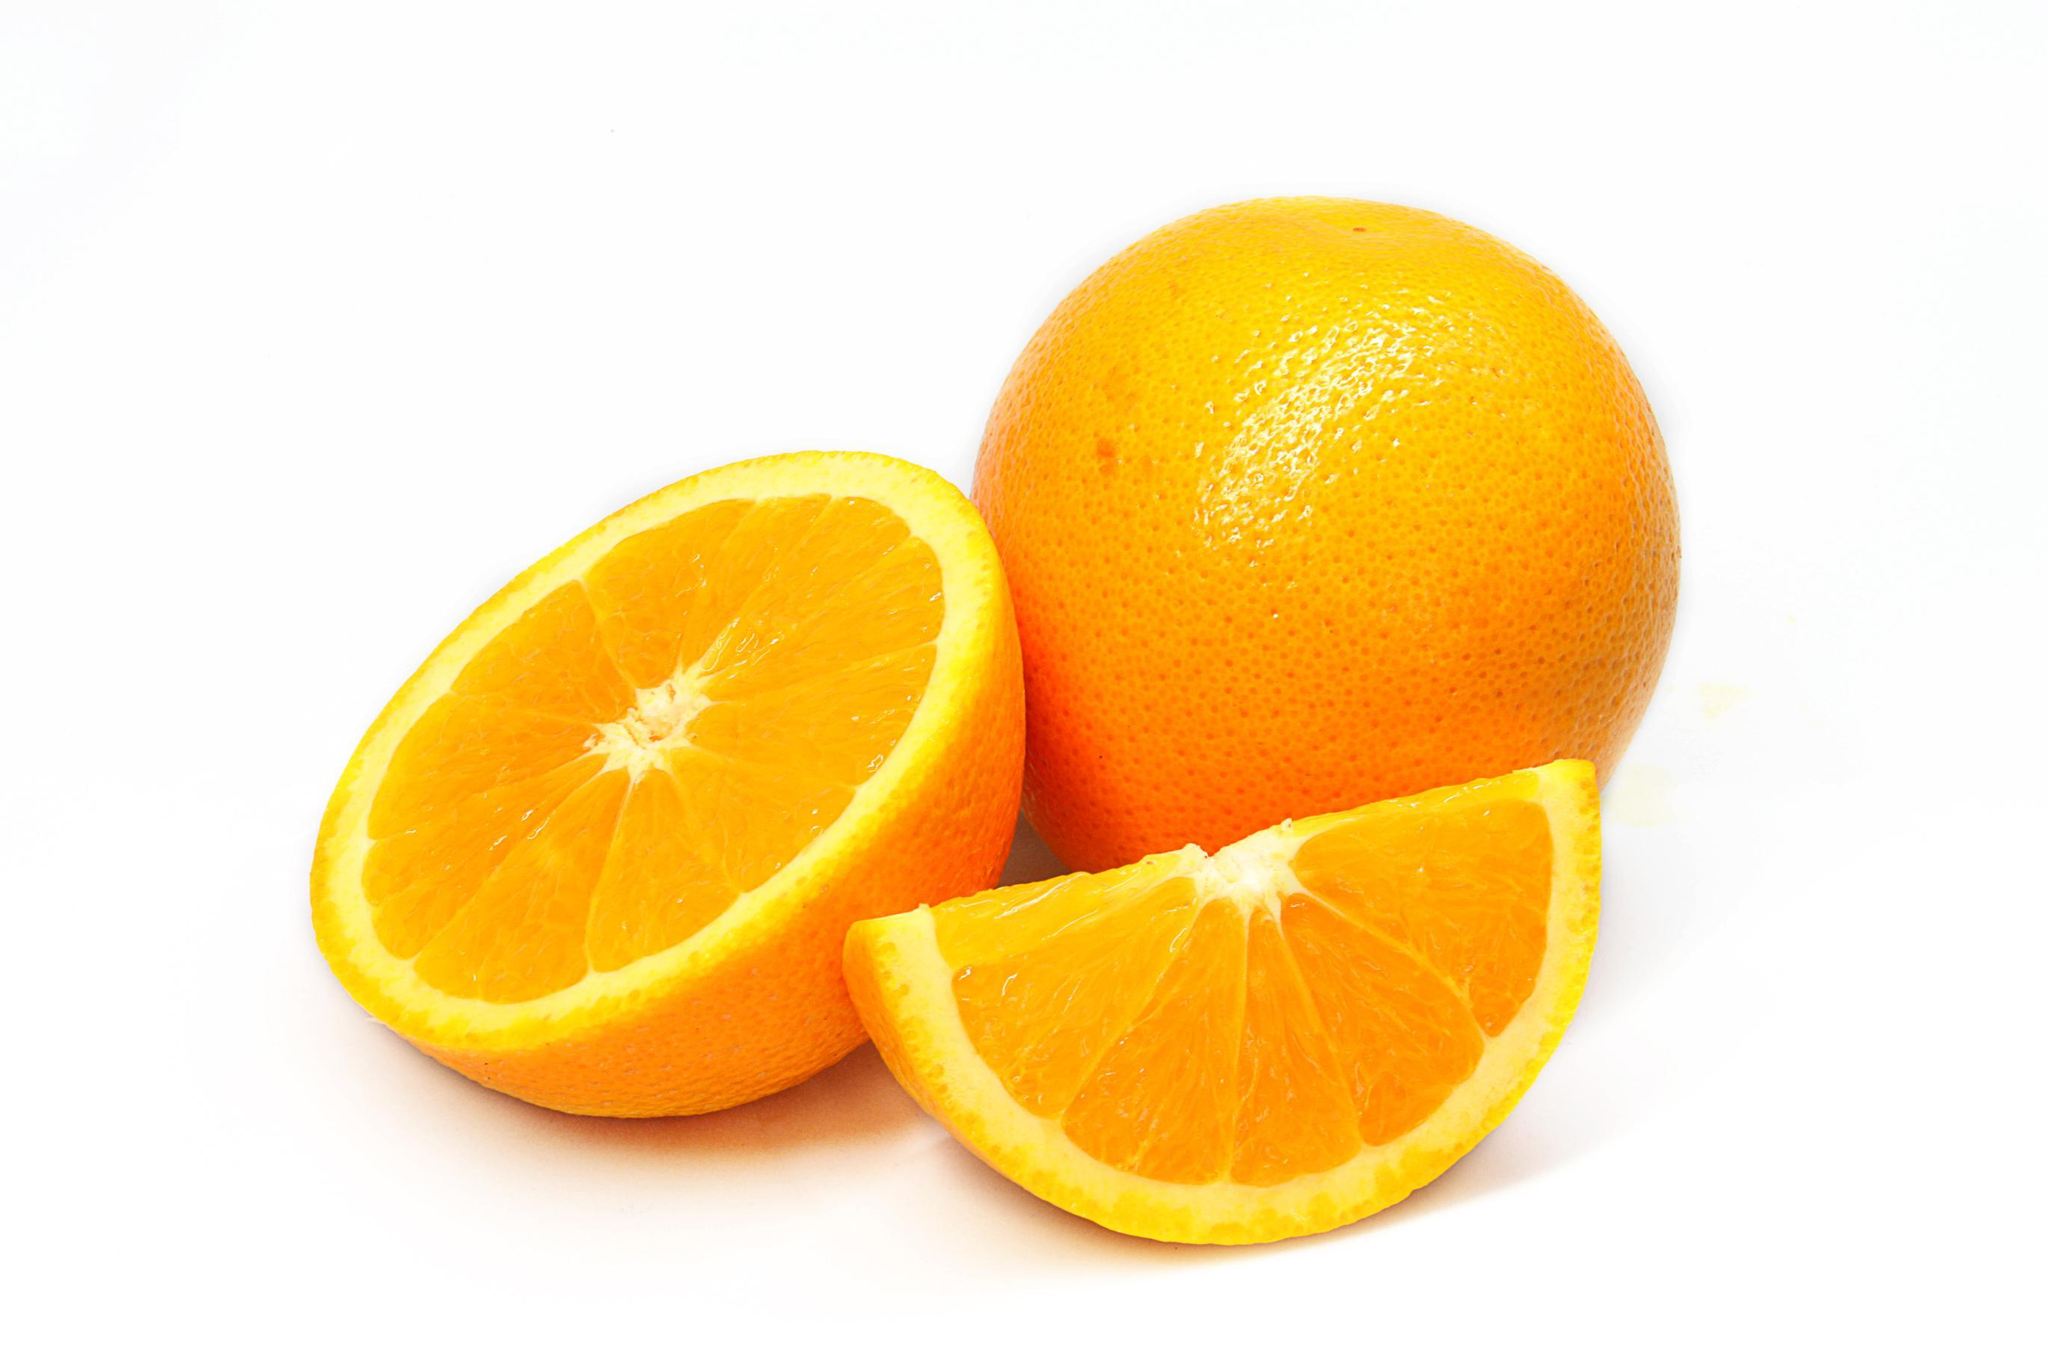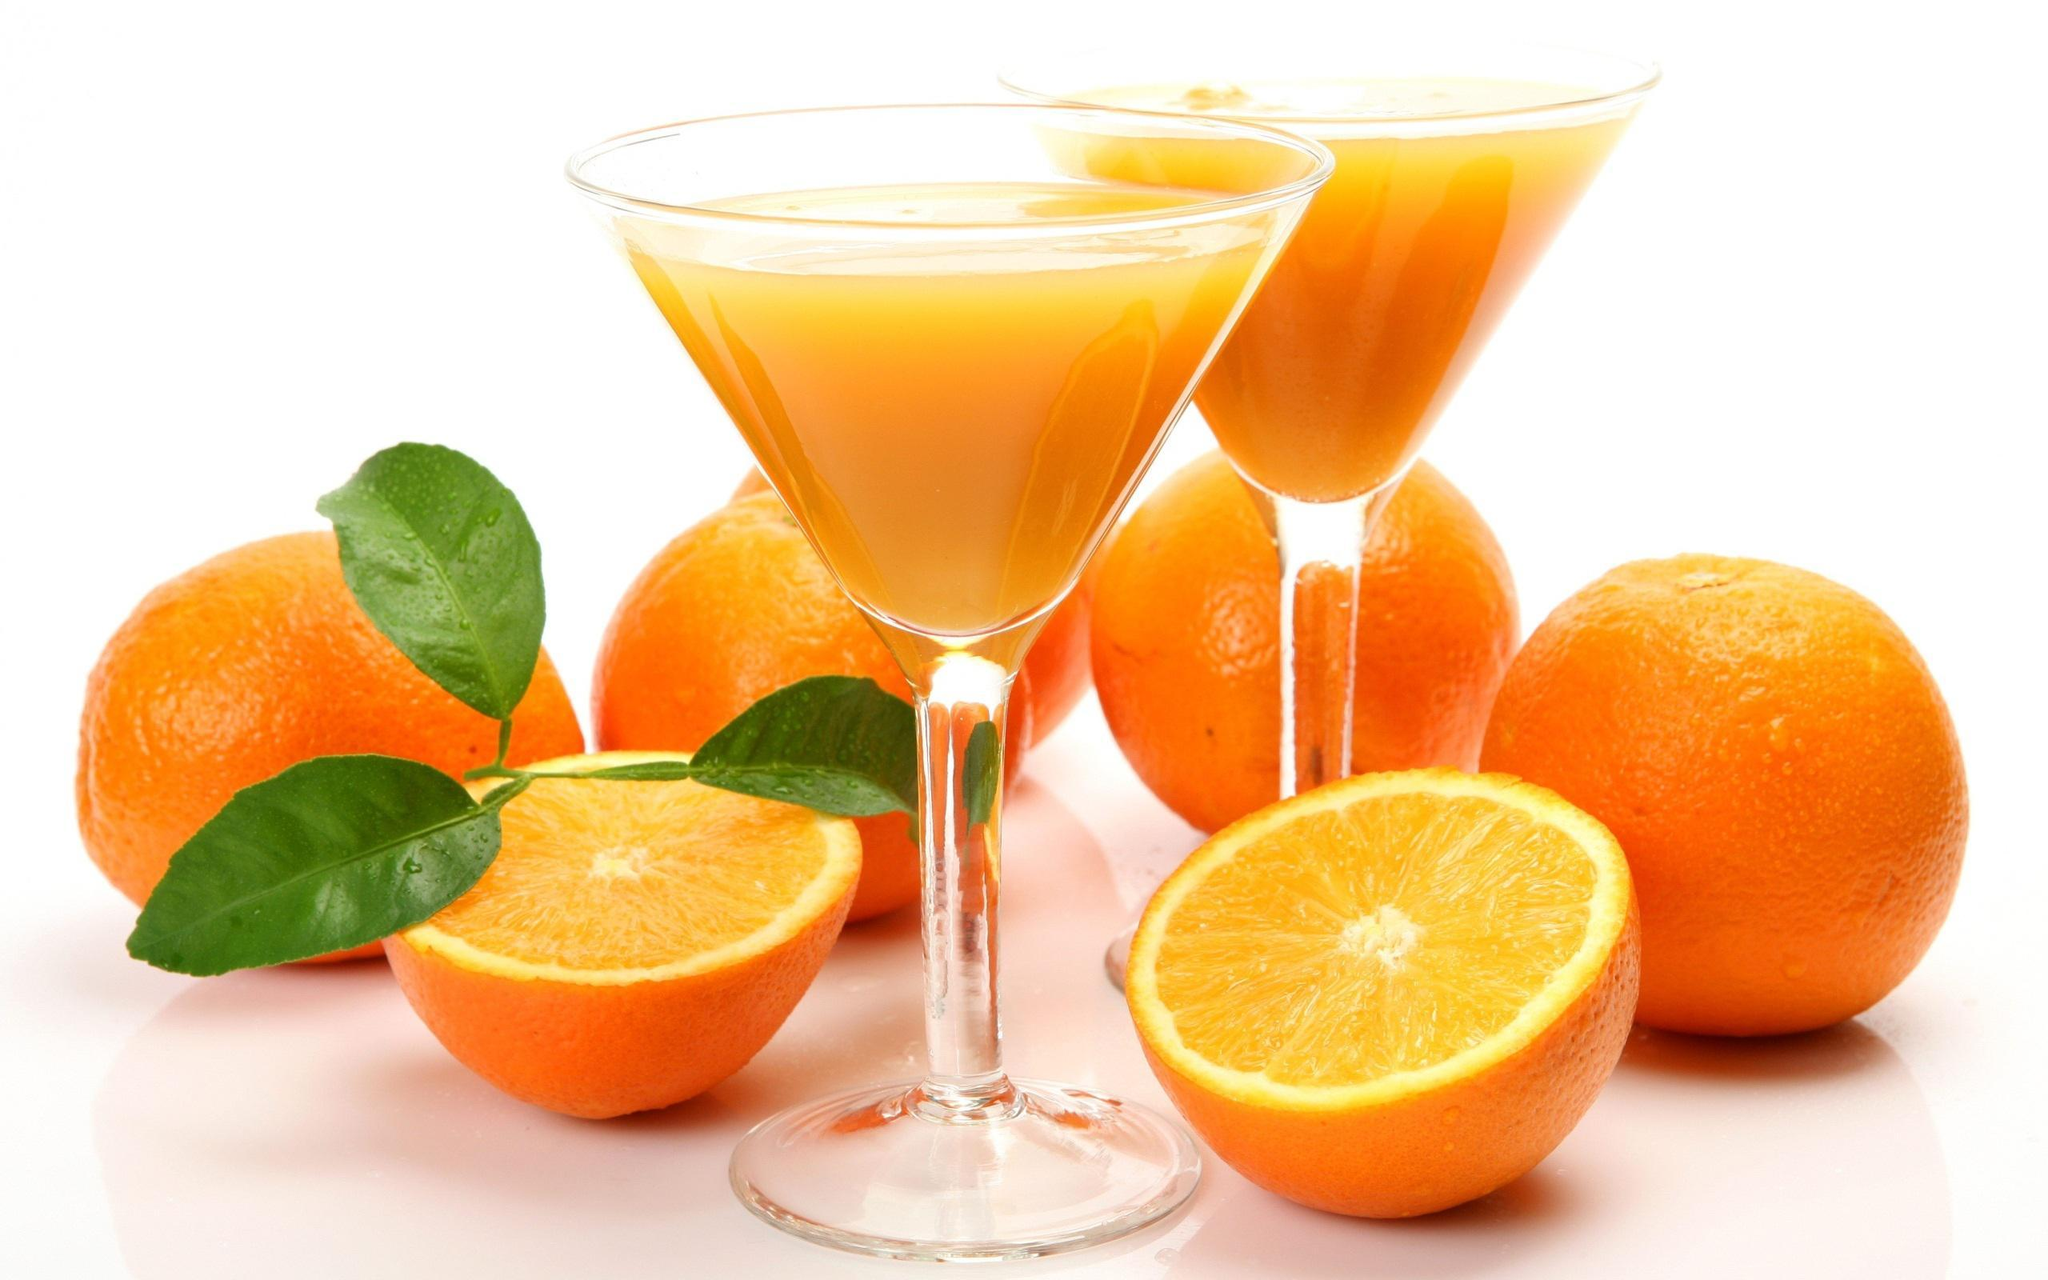The first image is the image on the left, the second image is the image on the right. Evaluate the accuracy of this statement regarding the images: "An orange WEDGE rests against a glass of juice.". Is it true? Answer yes or no. No. The first image is the image on the left, the second image is the image on the right. Assess this claim about the two images: "Glasses of orange juice without straws in them are present in at least one image.". Correct or not? Answer yes or no. Yes. 